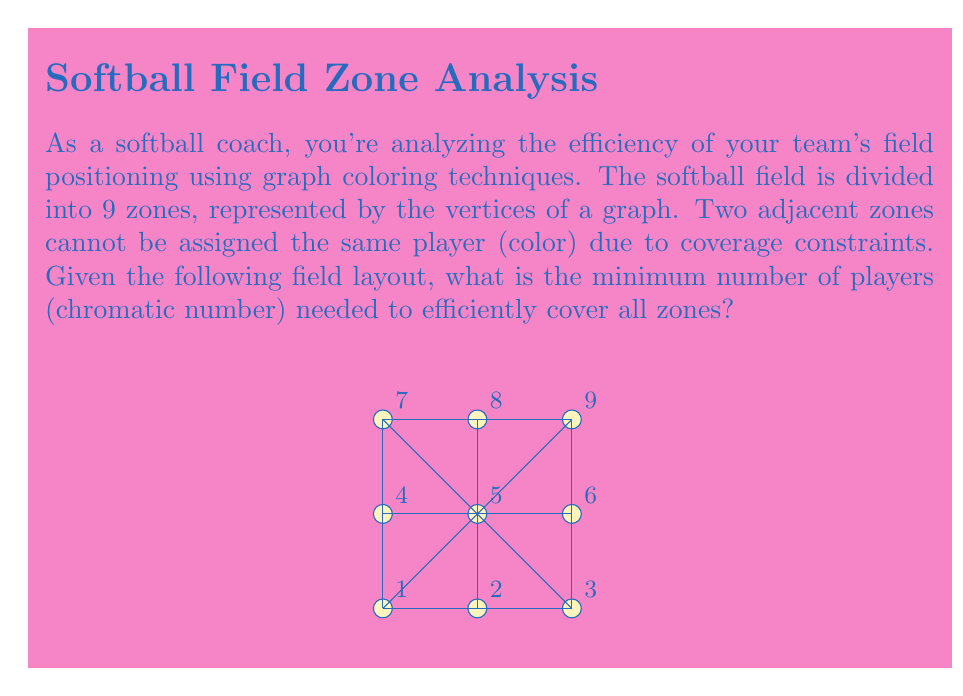Teach me how to tackle this problem. To solve this problem, we'll use graph coloring techniques:

1) First, we need to understand that each vertex (zone) in the graph represents an area of the field, and edges between vertices indicate adjacent zones.

2) The chromatic number of a graph is the minimum number of colors needed to color the vertices such that no two adjacent vertices have the same color.

3) We can start by analyzing the central vertex (5), which is connected to all other vertices. This means it must have a unique color.

4) The remaining vertices form a cycle of length 8. In graph theory, cycles of even length are 2-colorable.

5) Therefore, we can color the cycle using 2 colors, alternating between them as we go around the cycle.

6) The central vertex will require a third color.

7) We can verify that this coloring is valid:
   - Color 1: vertices 1, 3, 6, 8
   - Color 2: vertices 2, 4, 7, 9
   - Color 3: vertex 5

8) No two adjacent vertices have the same color, and we've used the minimum possible number of colors.

Thus, the chromatic number of this graph is 3, meaning a minimum of 3 players are needed to efficiently cover all zones of the field.
Answer: 3 